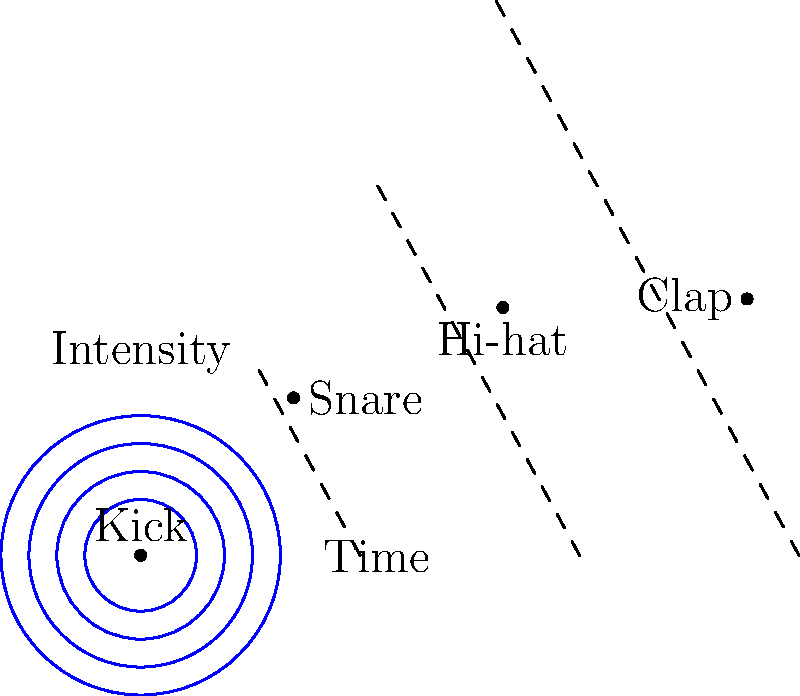In the polar coordinate representation of a rhythm pattern for an electro-pop composition, the angle represents time within a measure, and the radius represents intensity. Given the diagram, what would be the correct sequence of percussion elements if the composition is played clockwise starting from the topmost point? To answer this question, we need to analyze the polar coordinate diagram and interpret it in the context of rhythm patterns in electro-pop music. Let's break it down step-by-step:

1. In this polar coordinate system:
   - The angle ($\theta$) represents time within a measure
   - The radius ($r$) represents intensity

2. The diagram shows four points, each representing a percussion element:
   - At $\theta = 0$ (top): Kick drum with highest intensity ($r = 1$)
   - At $\theta = \frac{\pi}{2}$ (right): Snare with second-highest intensity ($r = 0.8$)
   - At $\theta = \pi$ (bottom): Hi-hat with third-highest intensity ($r = 0.6$)
   - At $\theta = \frac{3\pi}{2}$ (left): Clap with lowest intensity ($r = 0.4$)

3. The question asks for the sequence when played clockwise from the topmost point.

4. Starting from the top and moving clockwise, we encounter the percussion elements in this order:
   Kick → Snare → Hi-hat → Clap

This sequence represents a common rhythm pattern in electro-pop music, where the kick drum often starts the measure, followed by a snare on the backbeat, with hi-hats and claps adding rhythmic texture.
Answer: Kick, Snare, Hi-hat, Clap 